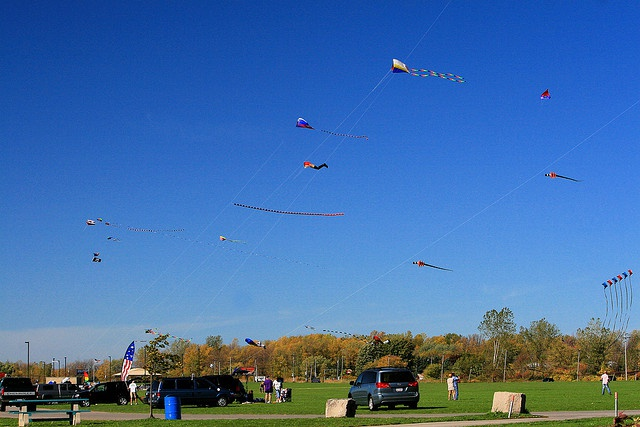Describe the objects in this image and their specific colors. I can see kite in darkblue, gray, darkgray, and black tones, truck in darkblue, black, gray, navy, and darkgreen tones, car in darkblue, black, blue, navy, and gray tones, car in darkblue, black, navy, gray, and darkgray tones, and bench in darkblue, black, darkgreen, teal, and tan tones in this image. 